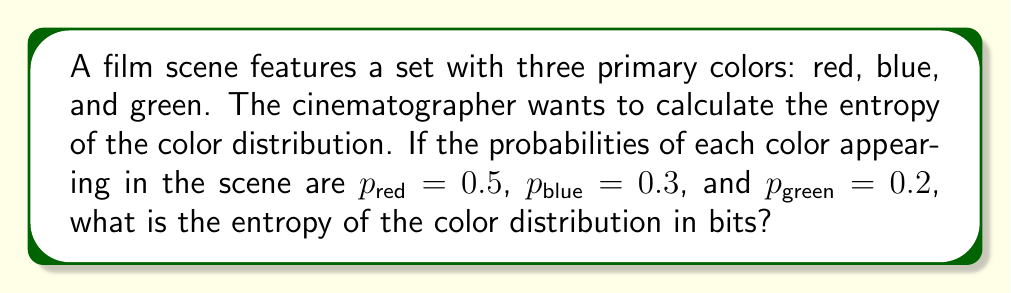Provide a solution to this math problem. To calculate the entropy of the color distribution, we'll use the Shannon entropy formula:

$$S = -\sum_{i} p_i \log_2(p_i)$$

Where $S$ is the entropy, $p_i$ is the probability of each color, and we use $\log_2$ to get the result in bits.

Step 1: Calculate each term in the sum:
- For red: $-0.5 \log_2(0.5) = 0.5$
- For blue: $-0.3 \log_2(0.3) \approx 0.521$
- For green: $-0.2 \log_2(0.2) \approx 0.464$

Step 2: Sum up all the terms:
$$S = 0.5 + 0.521 + 0.464 = 1.485$$

Therefore, the entropy of the color distribution in the film scene is approximately 1.485 bits.
Answer: 1.485 bits 